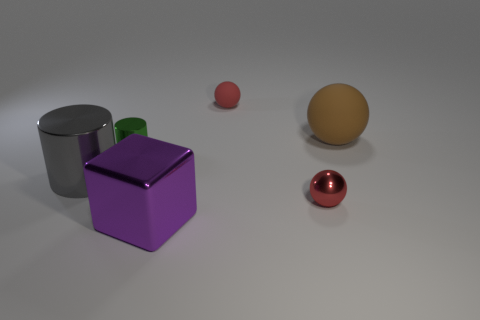Add 2 purple metal blocks. How many objects exist? 8 Subtract all cubes. How many objects are left? 5 Add 5 red things. How many red things exist? 7 Subtract 0 purple spheres. How many objects are left? 6 Subtract all blocks. Subtract all purple things. How many objects are left? 4 Add 1 matte balls. How many matte balls are left? 3 